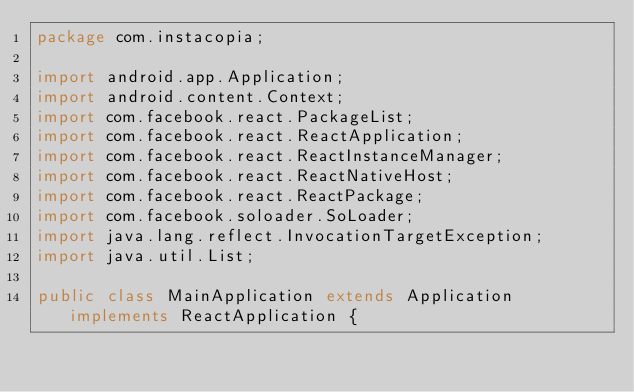<code> <loc_0><loc_0><loc_500><loc_500><_Java_>package com.instacopia;

import android.app.Application;
import android.content.Context;
import com.facebook.react.PackageList;
import com.facebook.react.ReactApplication;
import com.facebook.react.ReactInstanceManager;
import com.facebook.react.ReactNativeHost;
import com.facebook.react.ReactPackage;
import com.facebook.soloader.SoLoader;
import java.lang.reflect.InvocationTargetException;
import java.util.List;

public class MainApplication extends Application implements ReactApplication {
</code> 